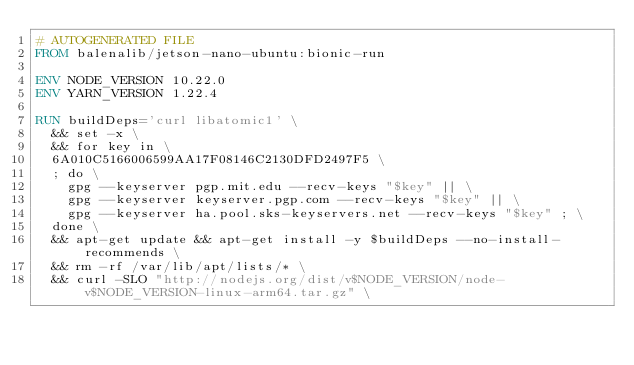Convert code to text. <code><loc_0><loc_0><loc_500><loc_500><_Dockerfile_># AUTOGENERATED FILE
FROM balenalib/jetson-nano-ubuntu:bionic-run

ENV NODE_VERSION 10.22.0
ENV YARN_VERSION 1.22.4

RUN buildDeps='curl libatomic1' \
	&& set -x \
	&& for key in \
	6A010C5166006599AA17F08146C2130DFD2497F5 \
	; do \
		gpg --keyserver pgp.mit.edu --recv-keys "$key" || \
		gpg --keyserver keyserver.pgp.com --recv-keys "$key" || \
		gpg --keyserver ha.pool.sks-keyservers.net --recv-keys "$key" ; \
	done \
	&& apt-get update && apt-get install -y $buildDeps --no-install-recommends \
	&& rm -rf /var/lib/apt/lists/* \
	&& curl -SLO "http://nodejs.org/dist/v$NODE_VERSION/node-v$NODE_VERSION-linux-arm64.tar.gz" \</code> 